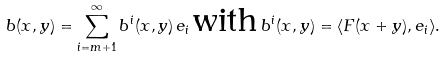Convert formula to latex. <formula><loc_0><loc_0><loc_500><loc_500>b ( x , y ) = \sum _ { i = m + 1 } ^ { \infty } b ^ { i } ( x , y ) \, e _ { i } \, \text {with} \, b ^ { i } ( x , y ) = \langle F ( x + y ) , e _ { i } \rangle .</formula> 